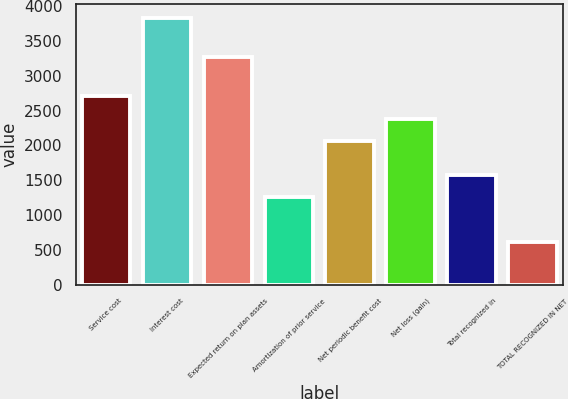Convert chart to OTSL. <chart><loc_0><loc_0><loc_500><loc_500><bar_chart><fcel>Service cost<fcel>Interest cost<fcel>Expected return on plan assets<fcel>Amortization of prior service<fcel>Net periodic benefit cost<fcel>Net loss (gain)<fcel>Total recognized in<fcel>TOTAL RECOGNIZED IN NET<nl><fcel>2707<fcel>3834<fcel>3267<fcel>1258<fcel>2063<fcel>2385<fcel>1580<fcel>614<nl></chart> 